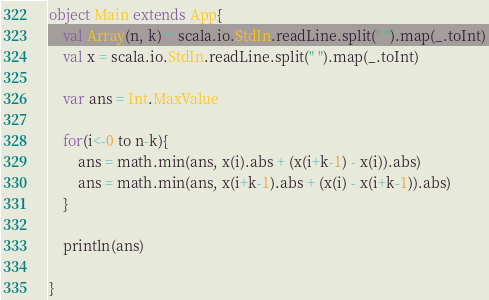Convert code to text. <code><loc_0><loc_0><loc_500><loc_500><_Scala_>object Main extends App{
    val Array(n, k) = scala.io.StdIn.readLine.split(" ").map(_.toInt)
   	val x = scala.io.StdIn.readLine.split(" ").map(_.toInt)

   	var ans = Int.MaxValue

   	for(i<-0 to n-k){
   		ans = math.min(ans, x(i).abs + (x(i+k-1) - x(i)).abs)
   		ans = math.min(ans, x(i+k-1).abs + (x(i) - x(i+k-1)).abs)
   	}

   	println(ans)

}
</code> 